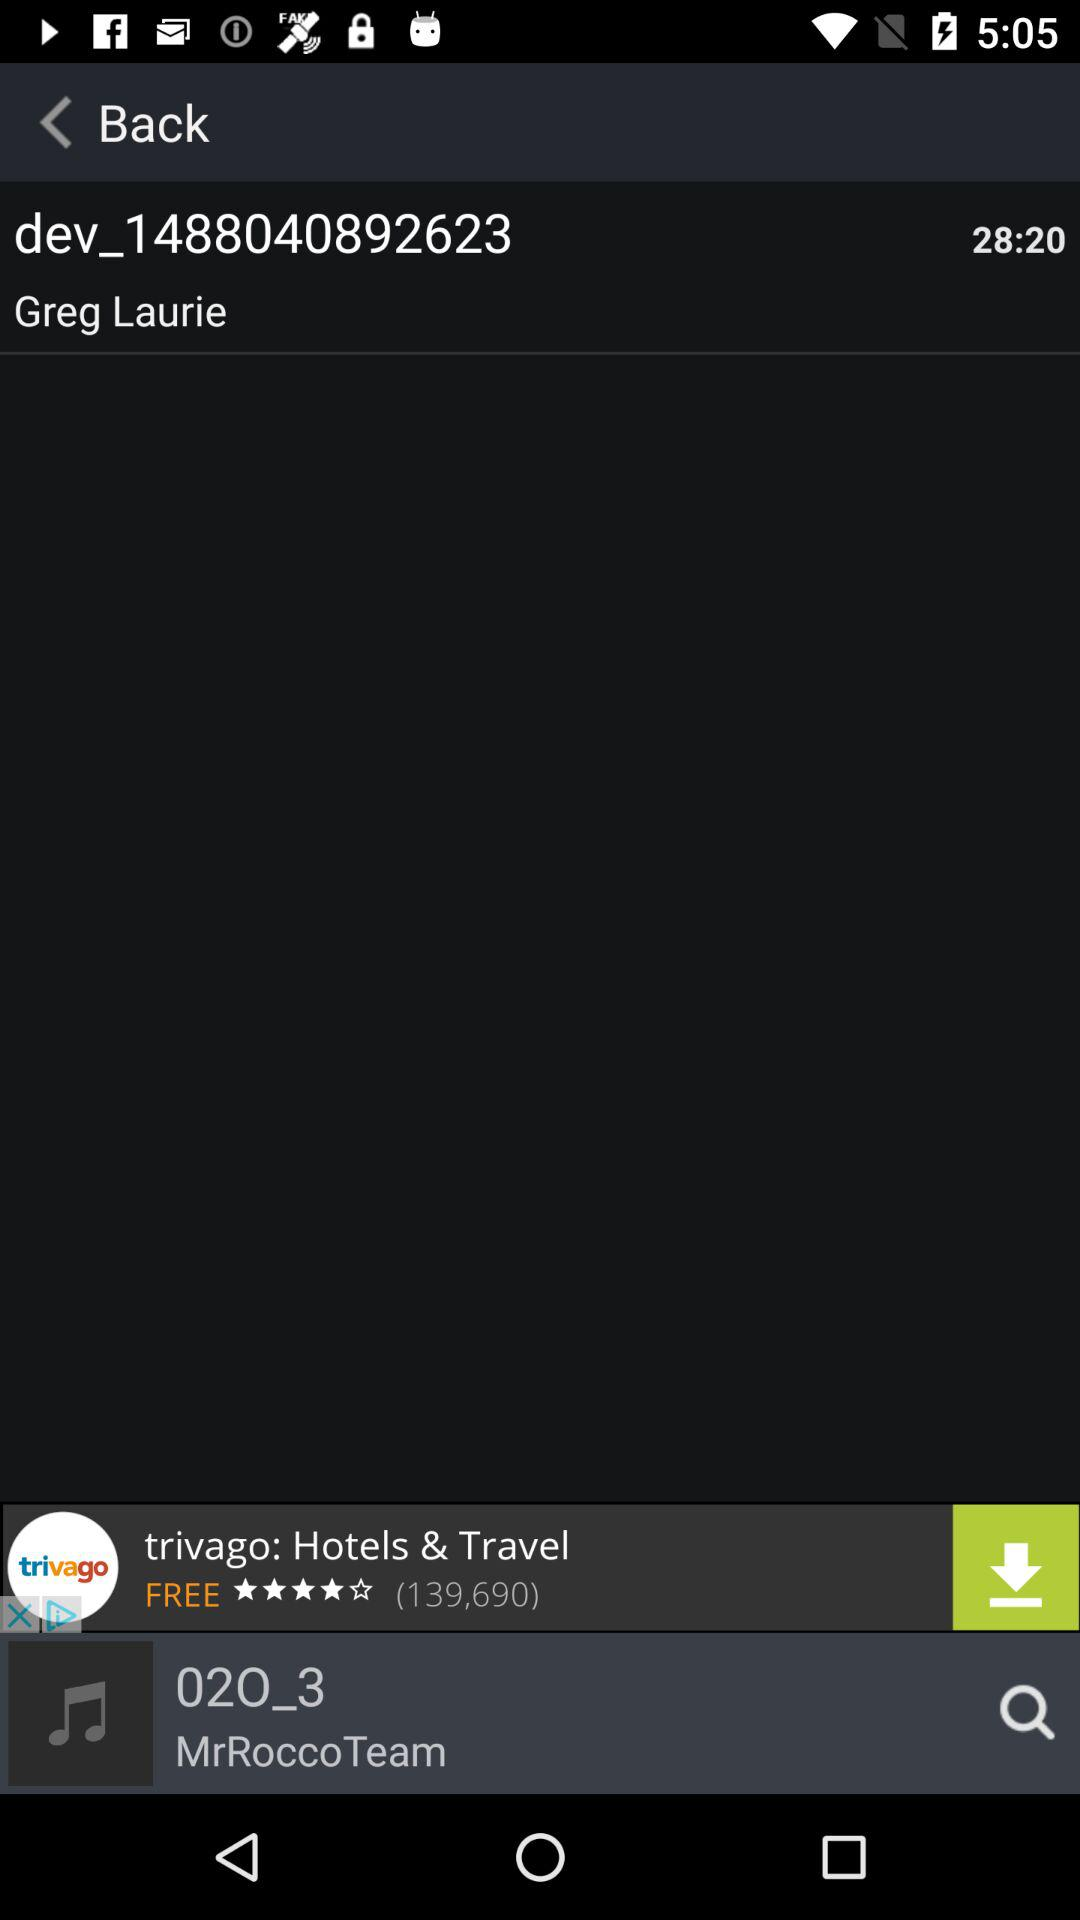Which song is currently playing? The song that is currently playing is "02O_3". 